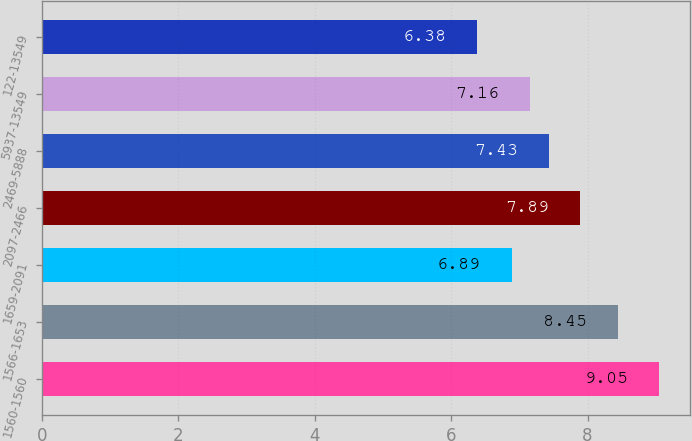Convert chart. <chart><loc_0><loc_0><loc_500><loc_500><bar_chart><fcel>1560-1560<fcel>1566-1653<fcel>1659-2091<fcel>2097-2466<fcel>2469-5888<fcel>5937-13549<fcel>122-13549<nl><fcel>9.05<fcel>8.45<fcel>6.89<fcel>7.89<fcel>7.43<fcel>7.16<fcel>6.38<nl></chart> 